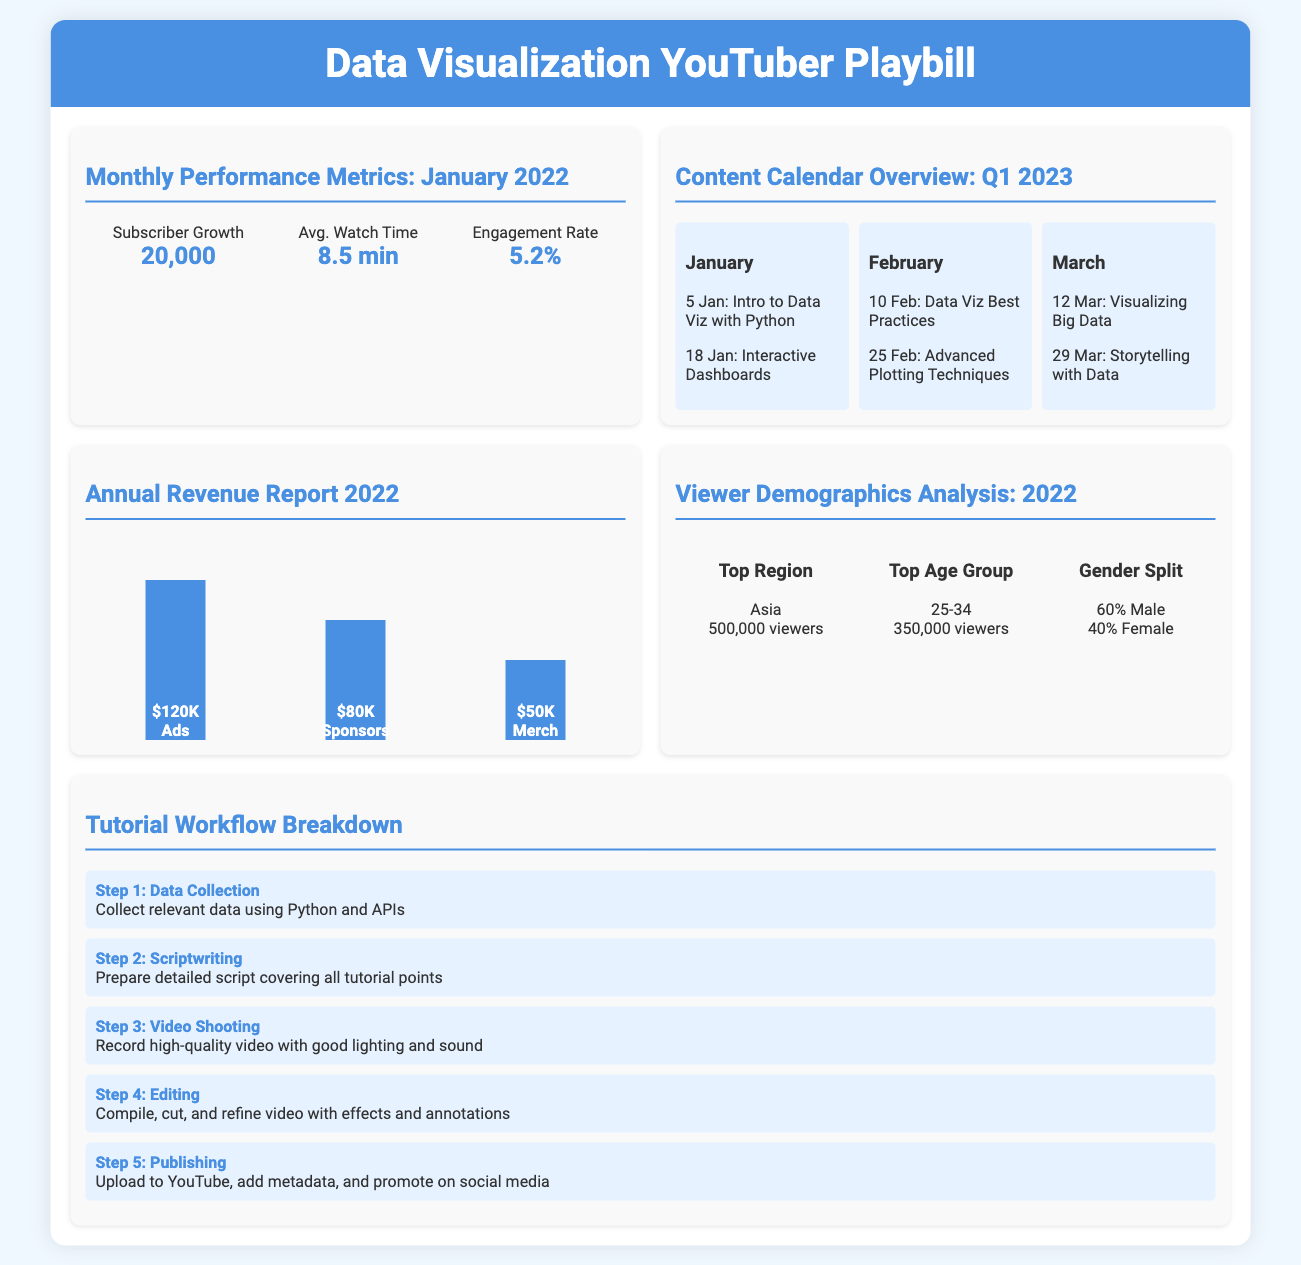What was the subscriber growth in January 2022? The document states that the subscriber growth was 20,000 in January 2022.
Answer: 20,000 What is the average watch time for January 2022? According to the metrics for January 2022, the average watch time is 8.5 minutes.
Answer: 8.5 min When is the video "Intro to Data Viz with Python" scheduled for release? The document lists the release date for this video as January 5.
Answer: 5 Jan How much revenue was generated from ads in 2022? The annual revenue report shows that $120,000 was generated from ads in 2022.
Answer: $120K What percentage of the audience is female based on the viewer demographics? The document states that 40% of the audience is female.
Answer: 40% Which age group has the highest viewer count? The demographics indicate that the age group 25-34 has the most viewers.
Answer: 25-34 What is the second step in the tutorial workflow? The document specifies that the second step of the workflow is "Scriptwriting."
Answer: Scriptwriting Which revenue source had the least income in 2022? The report indicates that merchandise made $50,000, the least compared to other sources.
Answer: Merch What is the total number of anticipated video topics in Q1 2023? The content calendar lists a total of 6 video topics for Q1 2023.
Answer: 6 